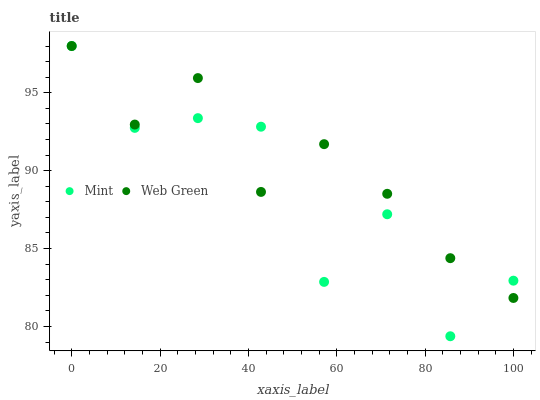Does Mint have the minimum area under the curve?
Answer yes or no. Yes. Does Web Green have the maximum area under the curve?
Answer yes or no. Yes. Does Web Green have the minimum area under the curve?
Answer yes or no. No. Is Web Green the smoothest?
Answer yes or no. Yes. Is Mint the roughest?
Answer yes or no. Yes. Is Web Green the roughest?
Answer yes or no. No. Does Mint have the lowest value?
Answer yes or no. Yes. Does Web Green have the lowest value?
Answer yes or no. No. Does Web Green have the highest value?
Answer yes or no. Yes. Does Web Green intersect Mint?
Answer yes or no. Yes. Is Web Green less than Mint?
Answer yes or no. No. Is Web Green greater than Mint?
Answer yes or no. No. 